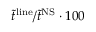<formula> <loc_0><loc_0><loc_500><loc_500>\tilde { t } ^ { l i n e } / \tilde { t } ^ { N S } \cdot 1 0 0</formula> 